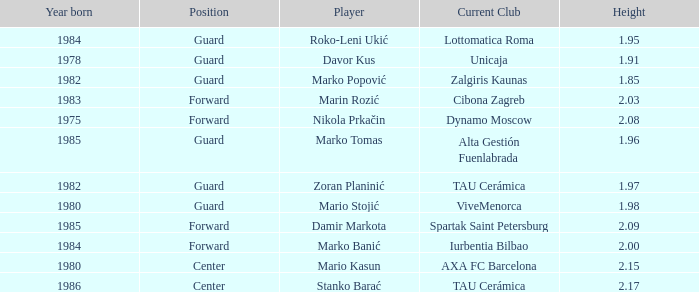What is the height of the player who currently plays for Alta Gestión Fuenlabrada? 1.96. 